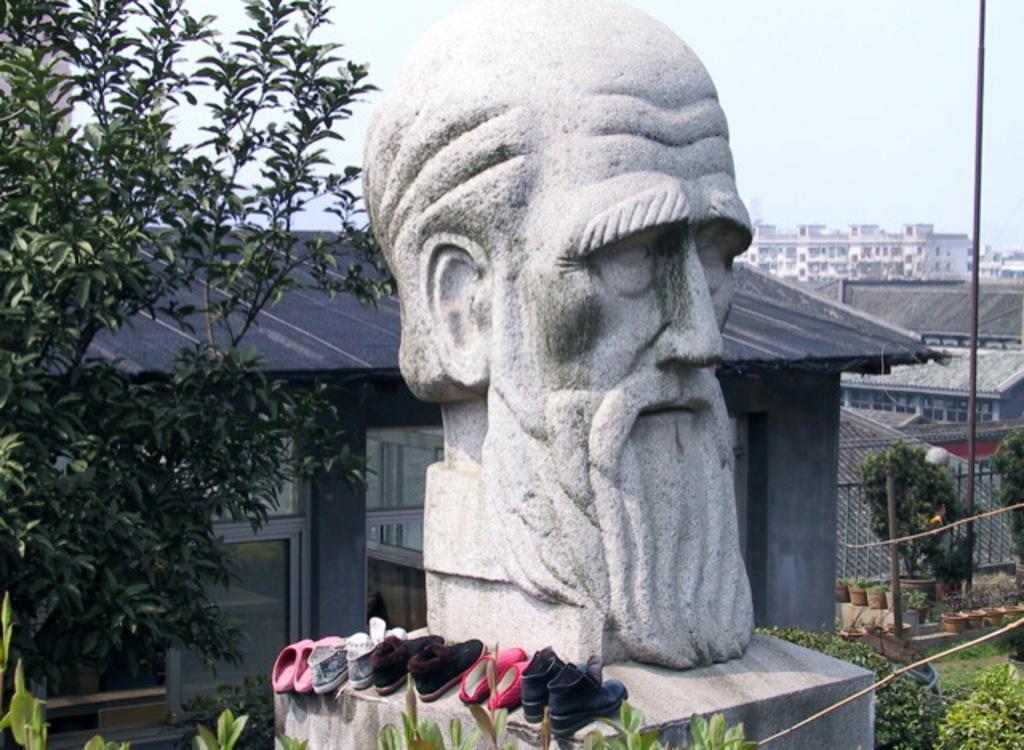Can you describe this image briefly? In this picture we can observe a statue of a person's head. We can observe some shoes placed beside the statue. There are some buildings and houses. We can observe trees and plants on the ground. On the right side there is a pole. In the background we can observe a sky. 